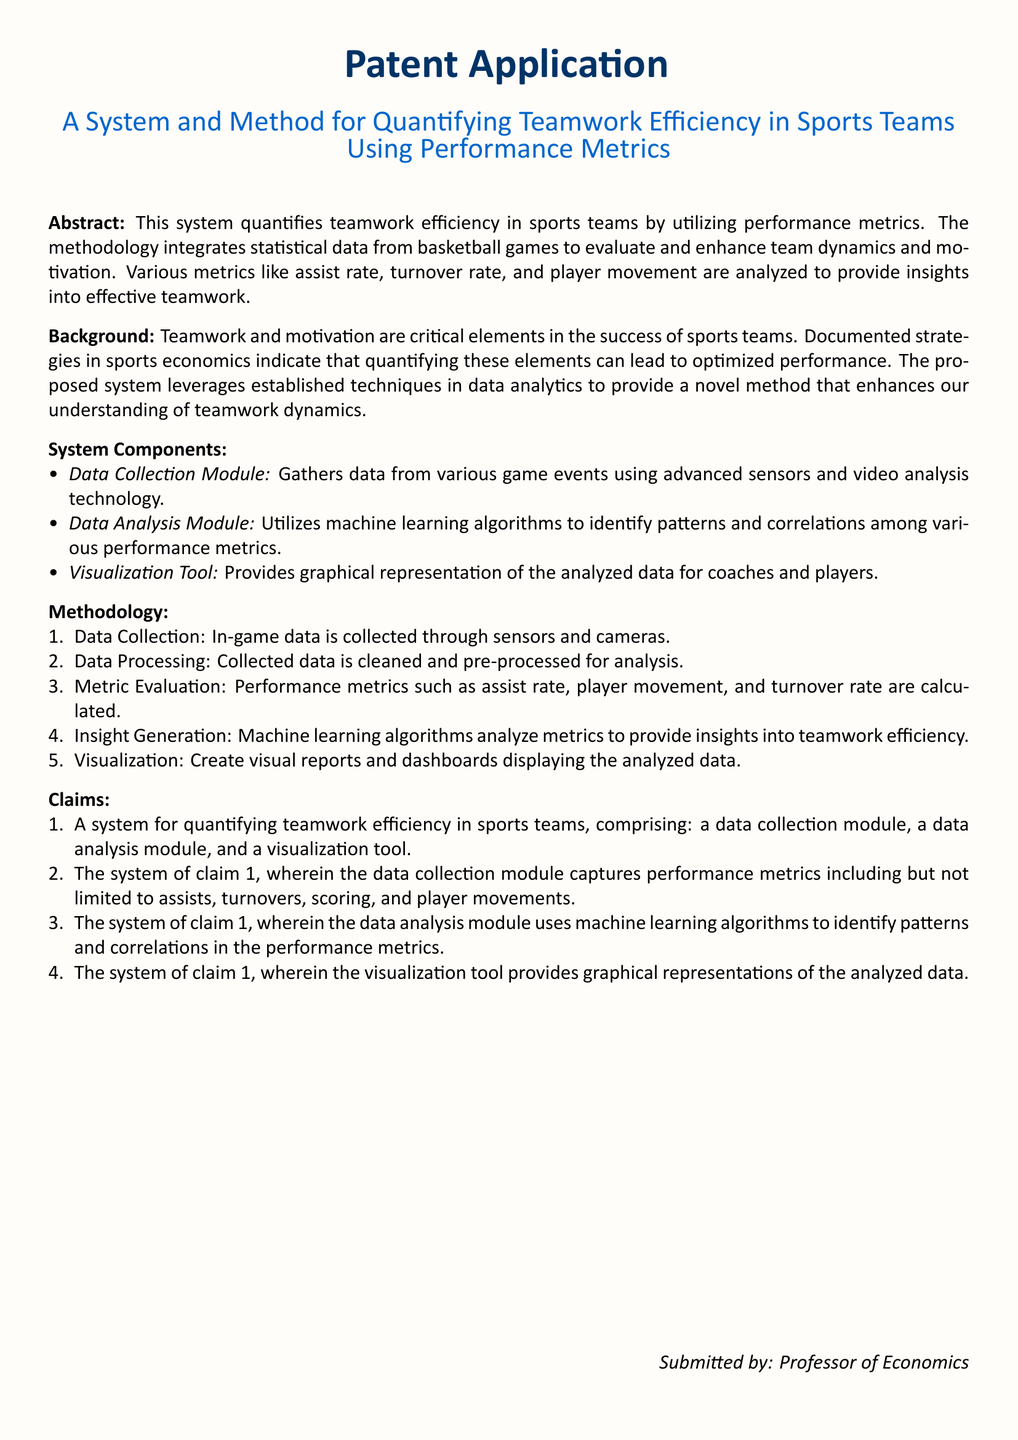What is the title of the patent application? The title of the patent application is stated clearly at the beginning of the document as "A System and Method for Quantifying Teamwork Efficiency in Sports Teams Using Performance Metrics."
Answer: A System and Method for Quantifying Teamwork Efficiency in Sports Teams Using Performance Metrics What are the key components of the system? The key components of the system are listed in the System Components section and include a Data Collection Module, a Data Analysis Module, and a Visualization Tool.
Answer: Data Collection Module, Data Analysis Module, Visualization Tool What performance metrics are mentioned? The performance metrics identified in the System and Methodology sections include assist rate, turnover rate, and player movement.
Answer: assist rate, turnover rate, player movement Which algorithms are used in the analysis module? The analysis module utilizes machine learning algorithms to identify patterns and correlations in performance metrics as stated in the Claims section.
Answer: machine learning algorithms What is the role of the Visualization Tool? The Visualization Tool provides graphical representations of the analyzed data for coaches and players, as indicated in the System Components section.
Answer: Graphical representations of the analyzed data How many steps are outlined in the methodology? The Methodology section lists five distinct steps involved in the process.
Answer: five Who submitted the patent application? The document specifies that the patent application was submitted by a Professor of Economics.
Answer: Professor of Economics 